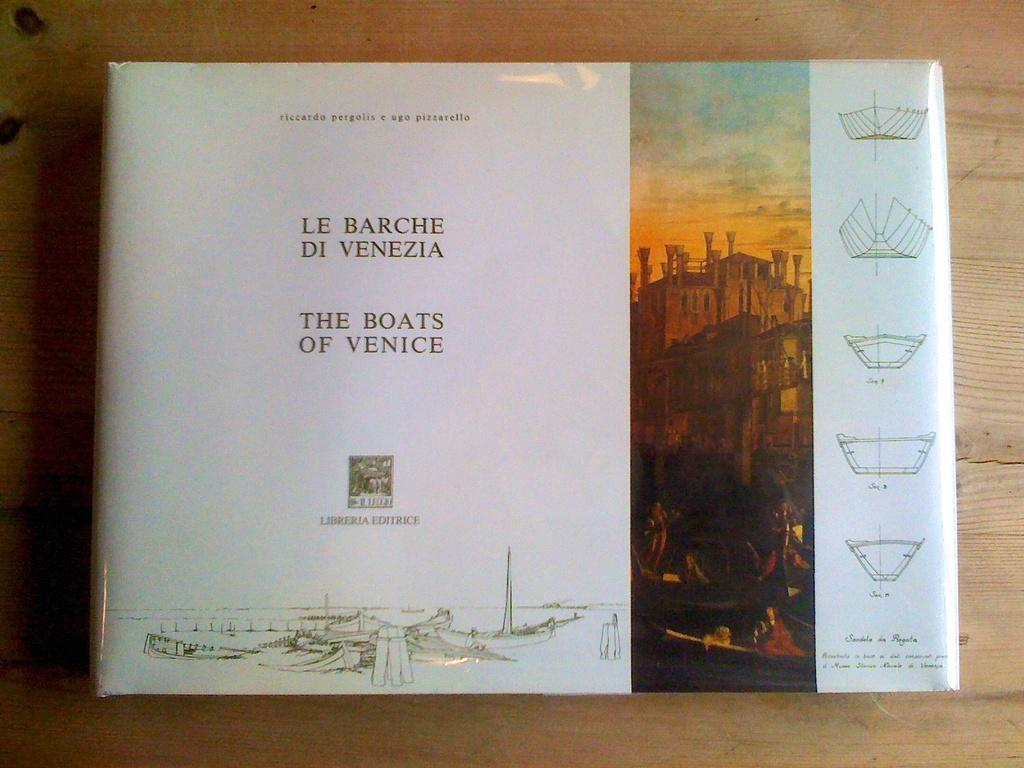<image>
Write a terse but informative summary of the picture. Book cover for "The Boats of Venice" showing people rowing in front of a city. 